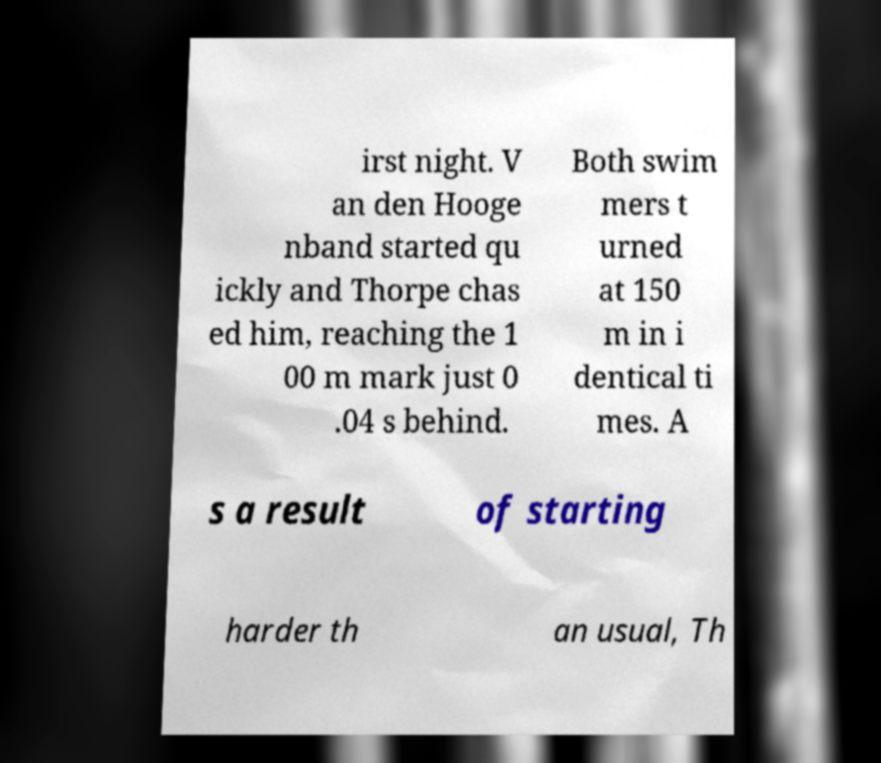Could you extract and type out the text from this image? irst night. V an den Hooge nband started qu ickly and Thorpe chas ed him, reaching the 1 00 m mark just 0 .04 s behind. Both swim mers t urned at 150 m in i dentical ti mes. A s a result of starting harder th an usual, Th 